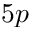Convert formula to latex. <formula><loc_0><loc_0><loc_500><loc_500>5 p</formula> 